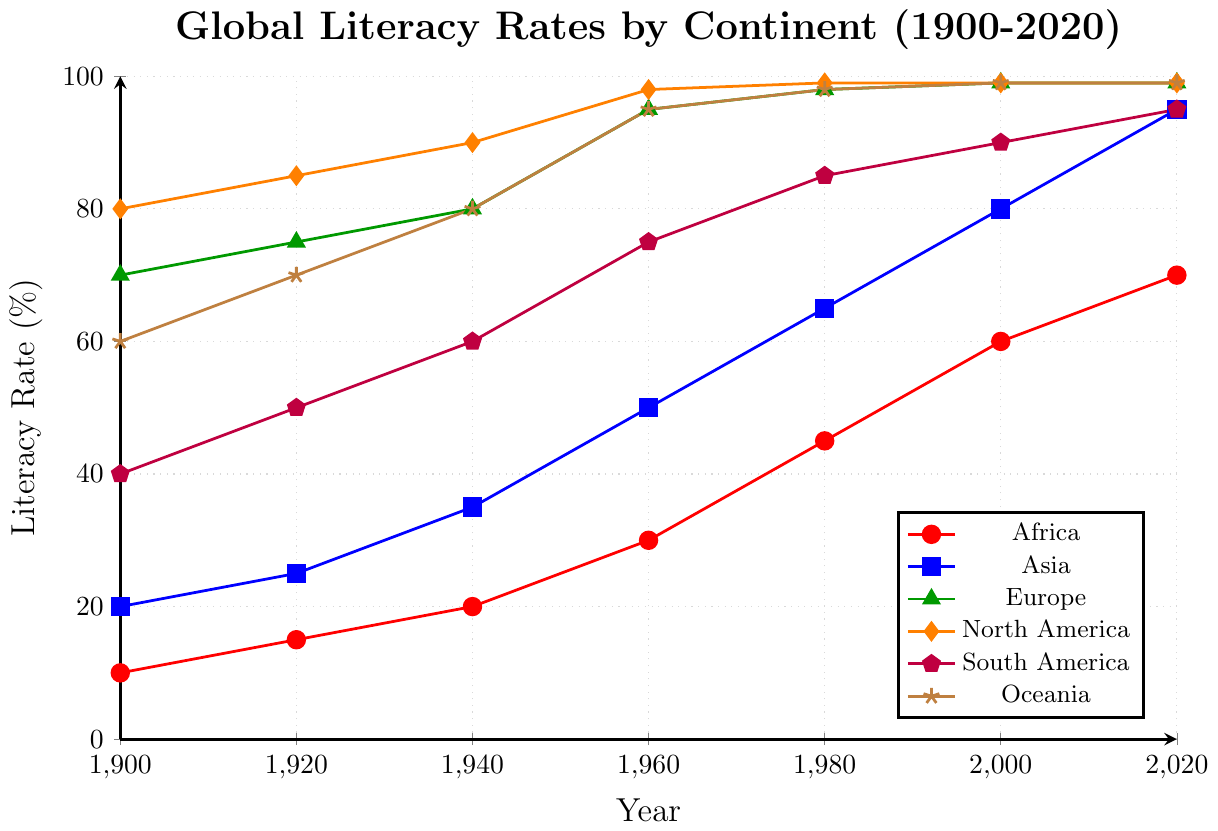What is the overall trend in literacy rates for Africa from 1900 to 2020? The literacy rate for Africa shows a steady increase over the years. It starts at 10% in 1900 and rises to 70% by 2020. To determine the trend, we observe the upward movement of the red line representing Africa.
Answer: Increasing trend Which continent had the highest literacy rate in 1900, and what was the value? To find this, we look at the initial data points for each continent in the figure. North America had the highest literacy rate at 80% in 1900, as indicated by the orange line.
Answer: North America, 80% By how many percentage points did the literacy rate in Asia increase from 1940 to 1980? For Asia, we subtract the literacy rate in 1940 from the rate in 1980. The figures are 65% in 1980 and 35% in 1940, giving an increase of 65 - 35 = 30 percentage points.
Answer: 30 percentage points What continent experienced the smallest increase in literacy rates between 1980 and 2020? By comparing the literacy rate differences for each continent between 1980 and 2020, Europe has the smallest increase since it was already at 98% in 1980 and moved to 99% in 2020, an increase of just 1 percentage point.
Answer: Europe Comparing literacy rates in 2020: which continents have an equal literacy rate? From the data in the figure, Europe, North America, and Oceania all have a literacy rate of 99% in 2020. This is seen by the colors green, orange, and brown lines converging at 99%.
Answer: Europe, North America, Oceania What was the average literacy rate of South America over the entire period? The values for South America are (40, 50, 60, 75, 85, 90, 95). Summing these gives 495. Dividing by the number of data points (7) gives an average of 495 / 7 ≈ 70.71%.
Answer: 70.71% By what percentage did the literacy rate in Oceania increase from 1900 to 2000? To find the percentage increase, subtract the 1900 rate from the 2000 rate and divide by the 1900 rate: (99 - 60) / 60 * 100 = 65%.
Answer: 65% Which continent had the fastest growth rate in literacy between 2000 and 2020? The fastest growth rate is calculated by the change over the period. Africa increased from 60% to 70% between 2000 and 2020, a rise of 10 percentage points. Other continents had smaller increases or were already near 100%.
Answer: Africa What is the difference in literacy rates between Europe and Africa in 1960? In 1960, the literacy rate for Europe was 95%, and for Africa, it was 30%. The difference is 95 - 30 = 65 percentage points.
Answer: 65 percentage points For each decade, which continent had consistent literacy rates (i.e., did not change)? From 2000 to 2020, Europe, North America, and Oceania had consistent rates, each maintaining 99% literacy over the two decades. This can be observed from the lines maintaining a constant value.
Answer: Europe, North America, Oceania 